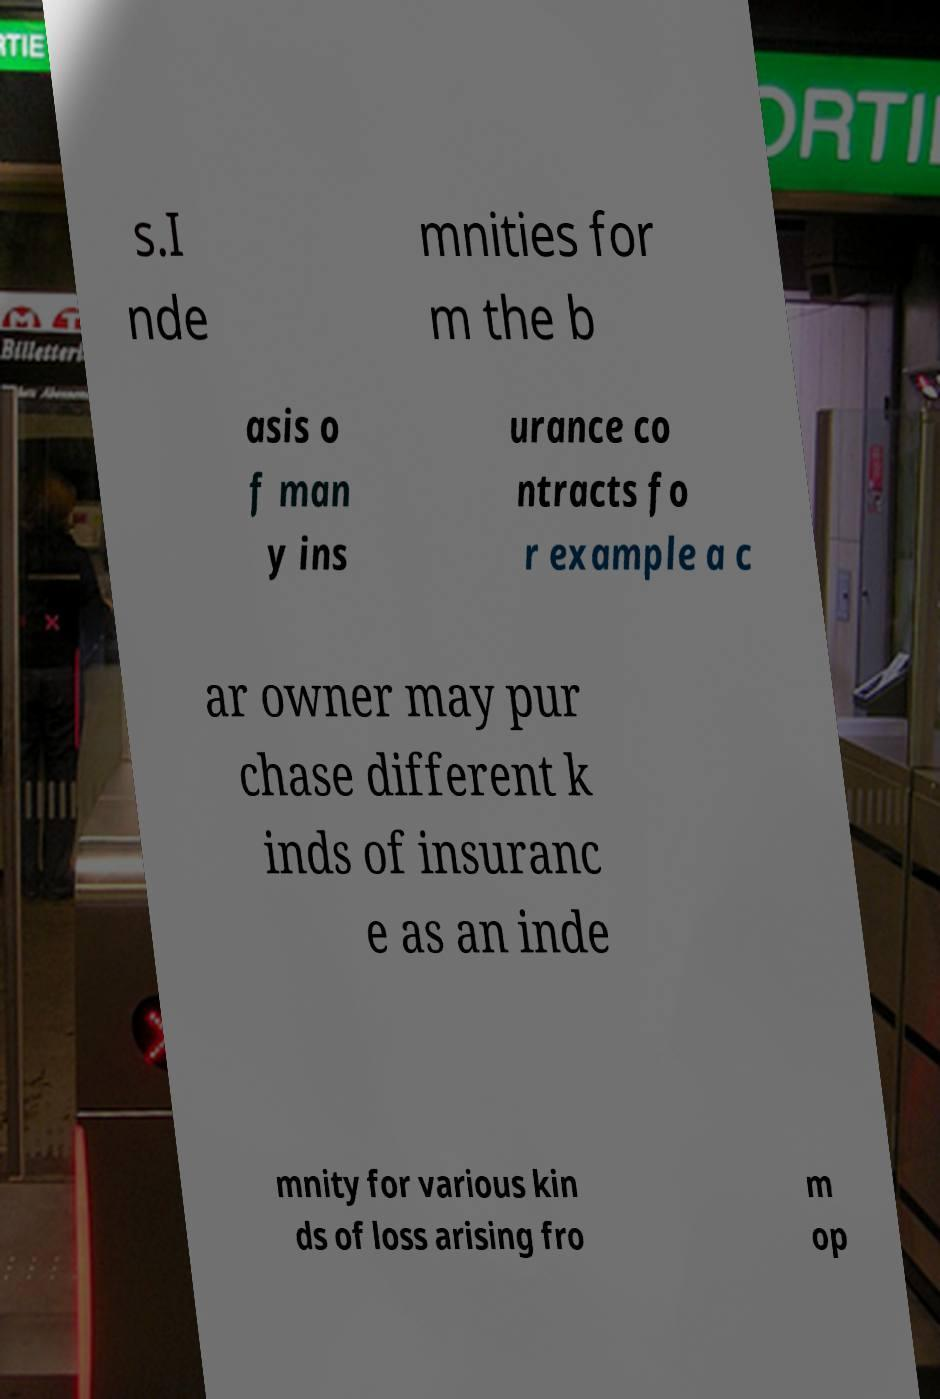Can you read and provide the text displayed in the image?This photo seems to have some interesting text. Can you extract and type it out for me? s.I nde mnities for m the b asis o f man y ins urance co ntracts fo r example a c ar owner may pur chase different k inds of insuranc e as an inde mnity for various kin ds of loss arising fro m op 